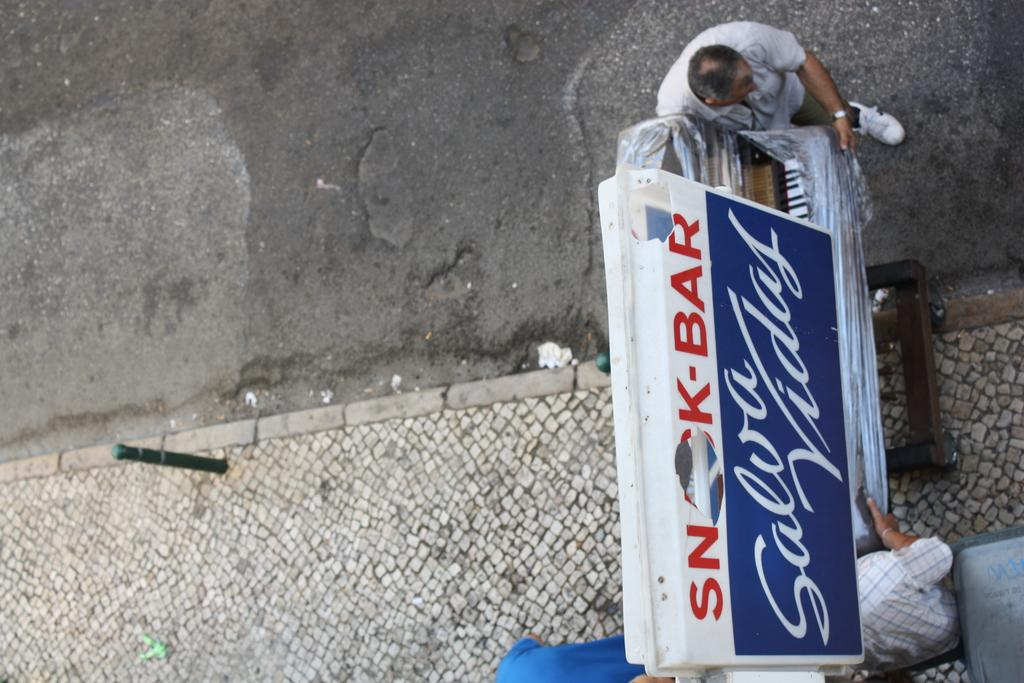What type of path is visible in the image? There is a footpath in the image. What other feature can be seen alongside the footpath? There is a road in the image. What object is present near the road and footpath? There is a pole in the image. What signage is visible in the image? There is a name board in the image. What structure is present in the image? There is a stand in the image. How many people are in the image? There are three people in the image. What other items can be seen in the image? There are some objects in the image. What type of boot is being used by one of the people in the image? There is no boot visible in the image; the people are not wearing any footwear. What type of cloth is being used to cover the stand in the image? There is no cloth covering the stand in the image; it is not mentioned in the facts. 